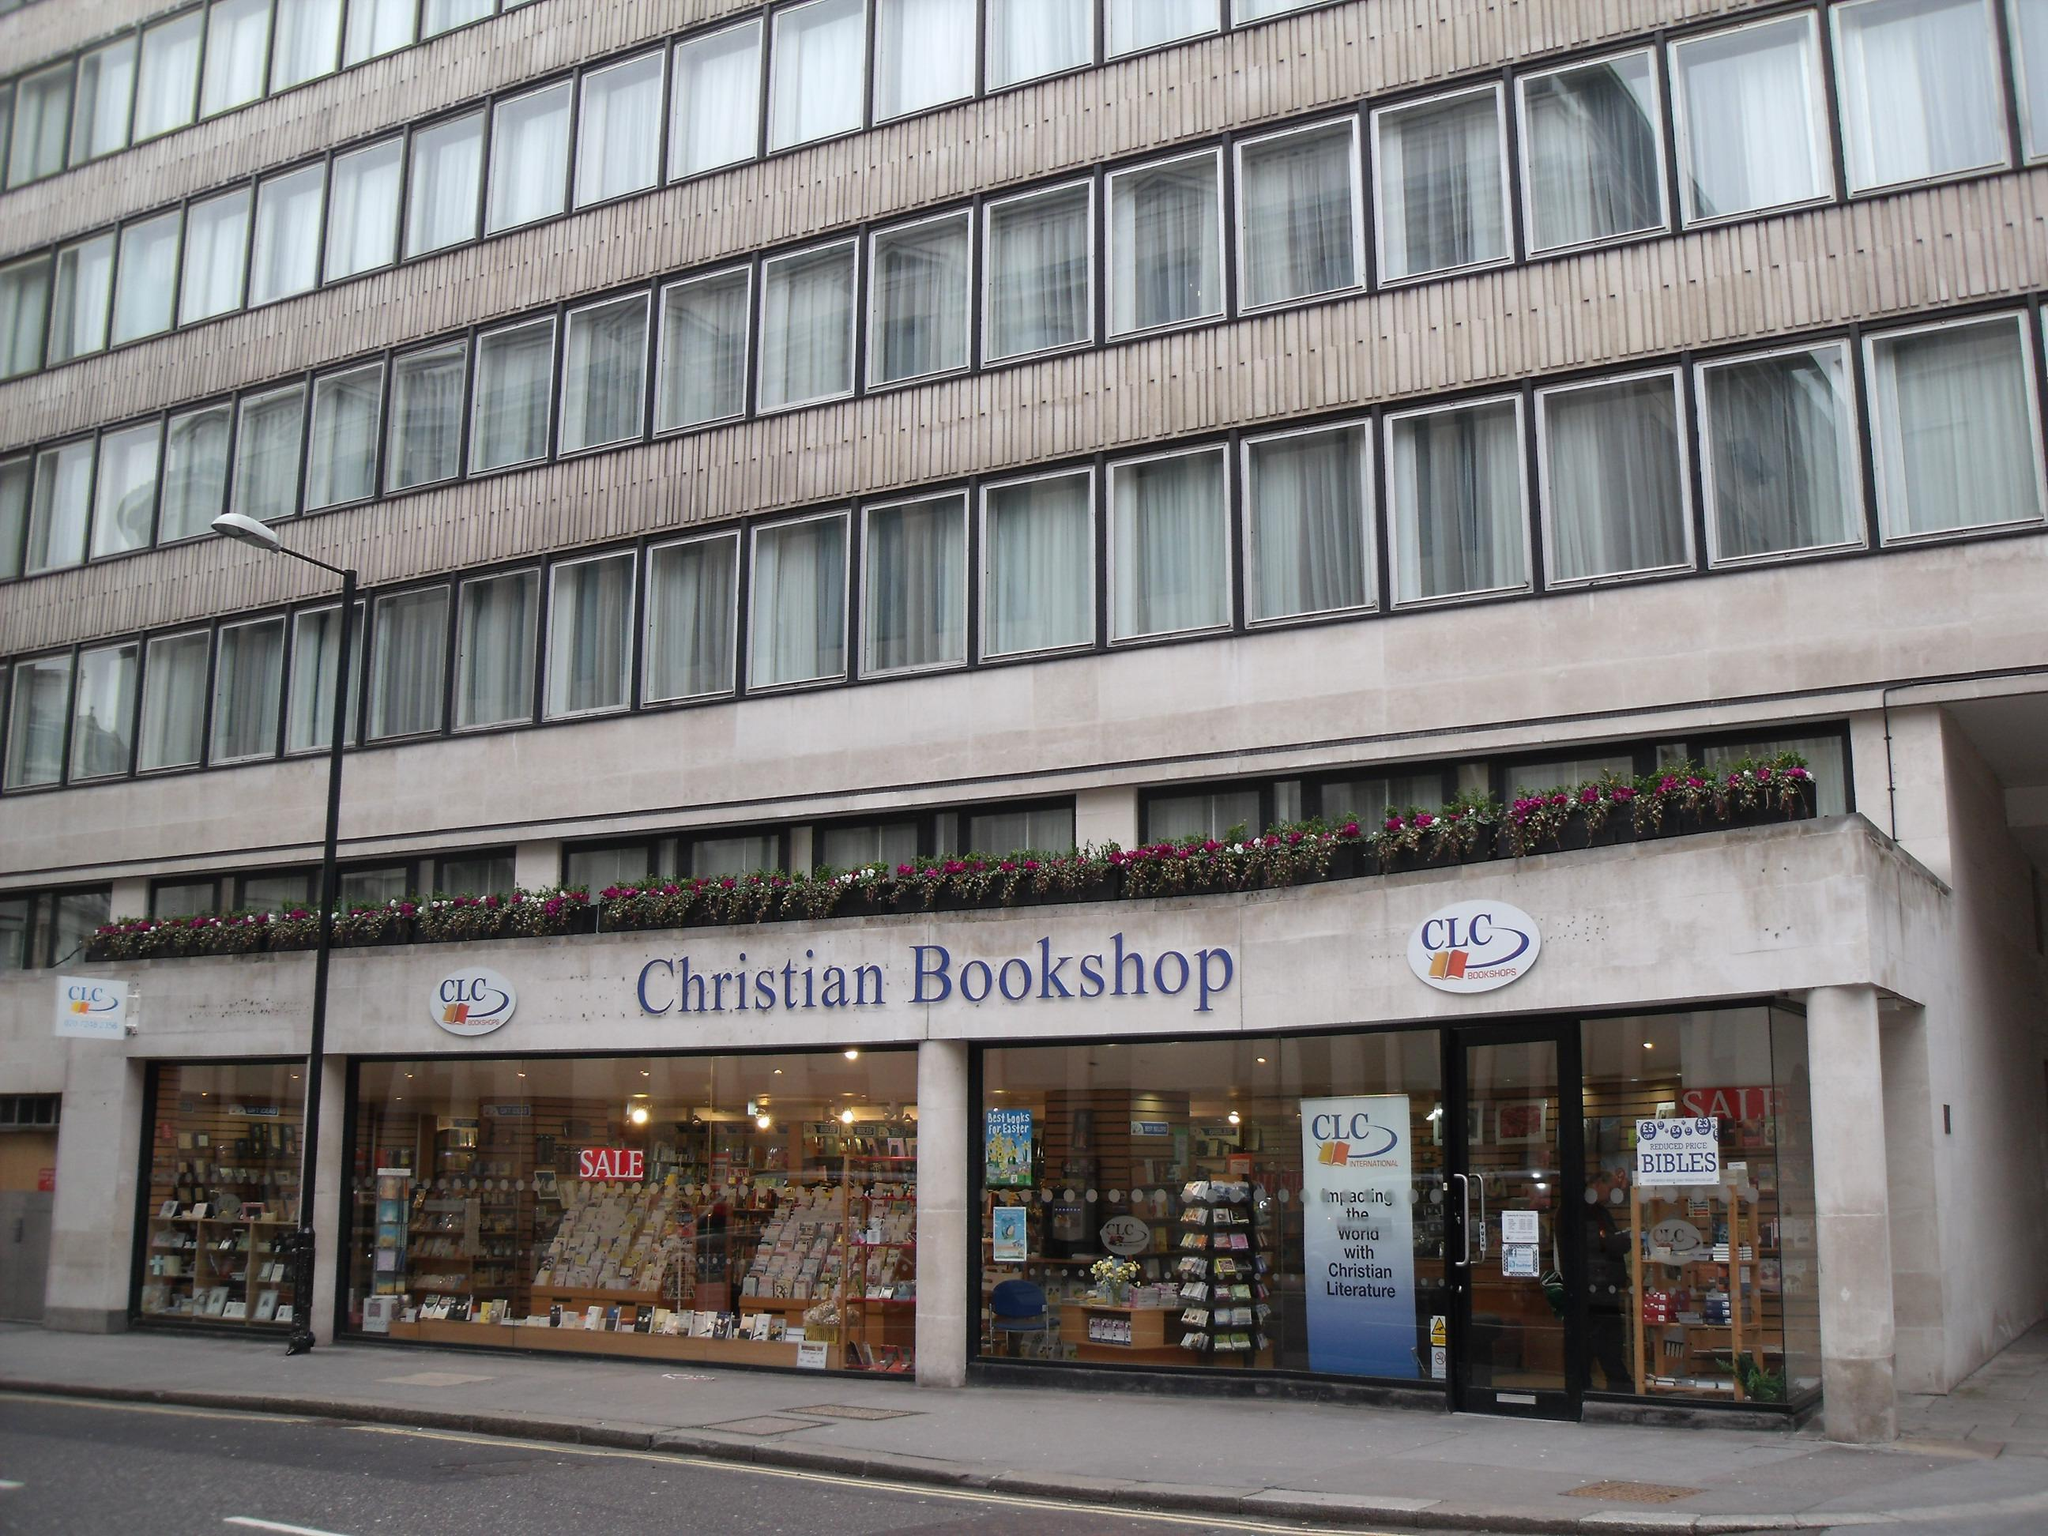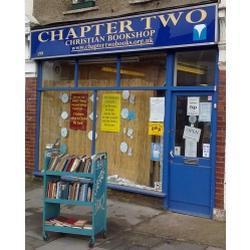The first image is the image on the left, the second image is the image on the right. Evaluate the accuracy of this statement regarding the images: "The right image shows a bookstore with a blue exterior, a large display window only to the left of one door, and four rectangular panes of glass under its sign.". Is it true? Answer yes or no. Yes. The first image is the image on the left, the second image is the image on the right. Examine the images to the left and right. Is the description "The bookstore name is in white with a blue background." accurate? Answer yes or no. Yes. 